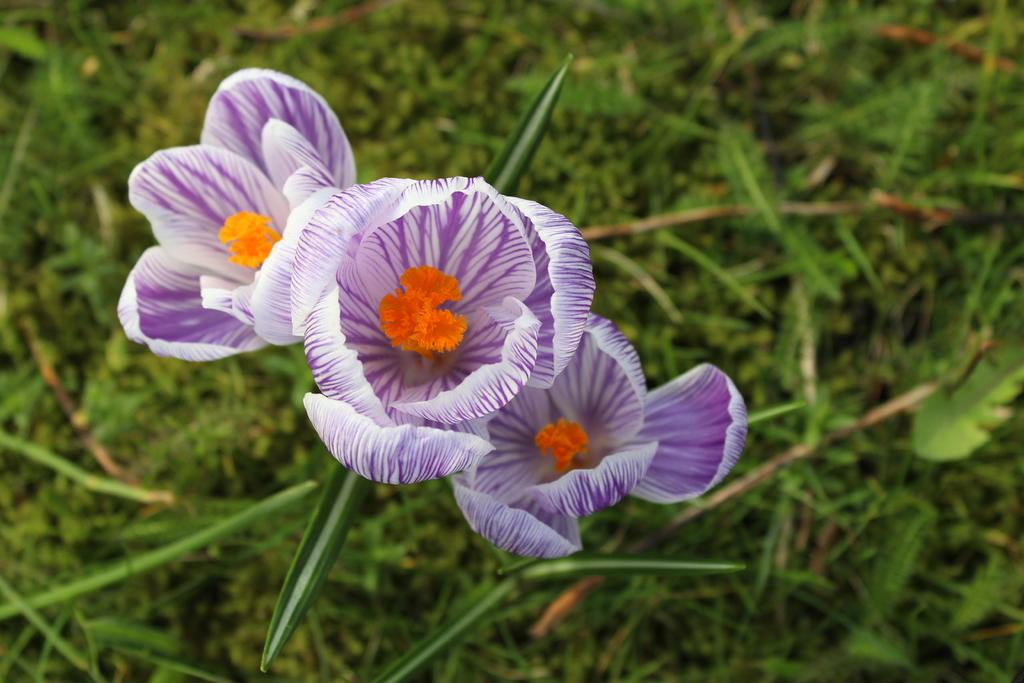What type of plant can be seen in the image? There is a flowering plant in the image. What type of vegetation is present in the image besides the flowering plant? There is grass in the image. Where might this image have been taken? The image is likely taken in a garden. At what time of day was the image likely taken? The image is likely taken during the day. What type of needle is being used by the father in the image? There is no father or needle present in the image. 